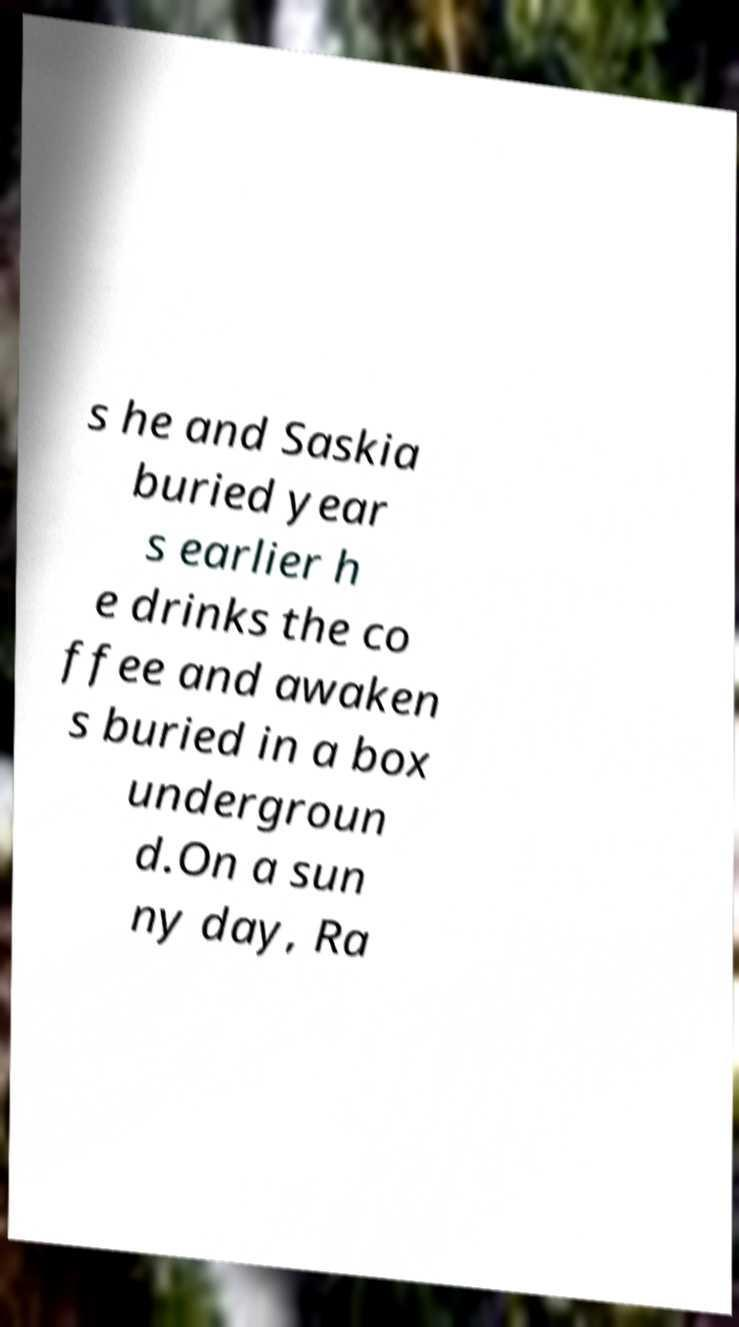Please read and relay the text visible in this image. What does it say? s he and Saskia buried year s earlier h e drinks the co ffee and awaken s buried in a box undergroun d.On a sun ny day, Ra 